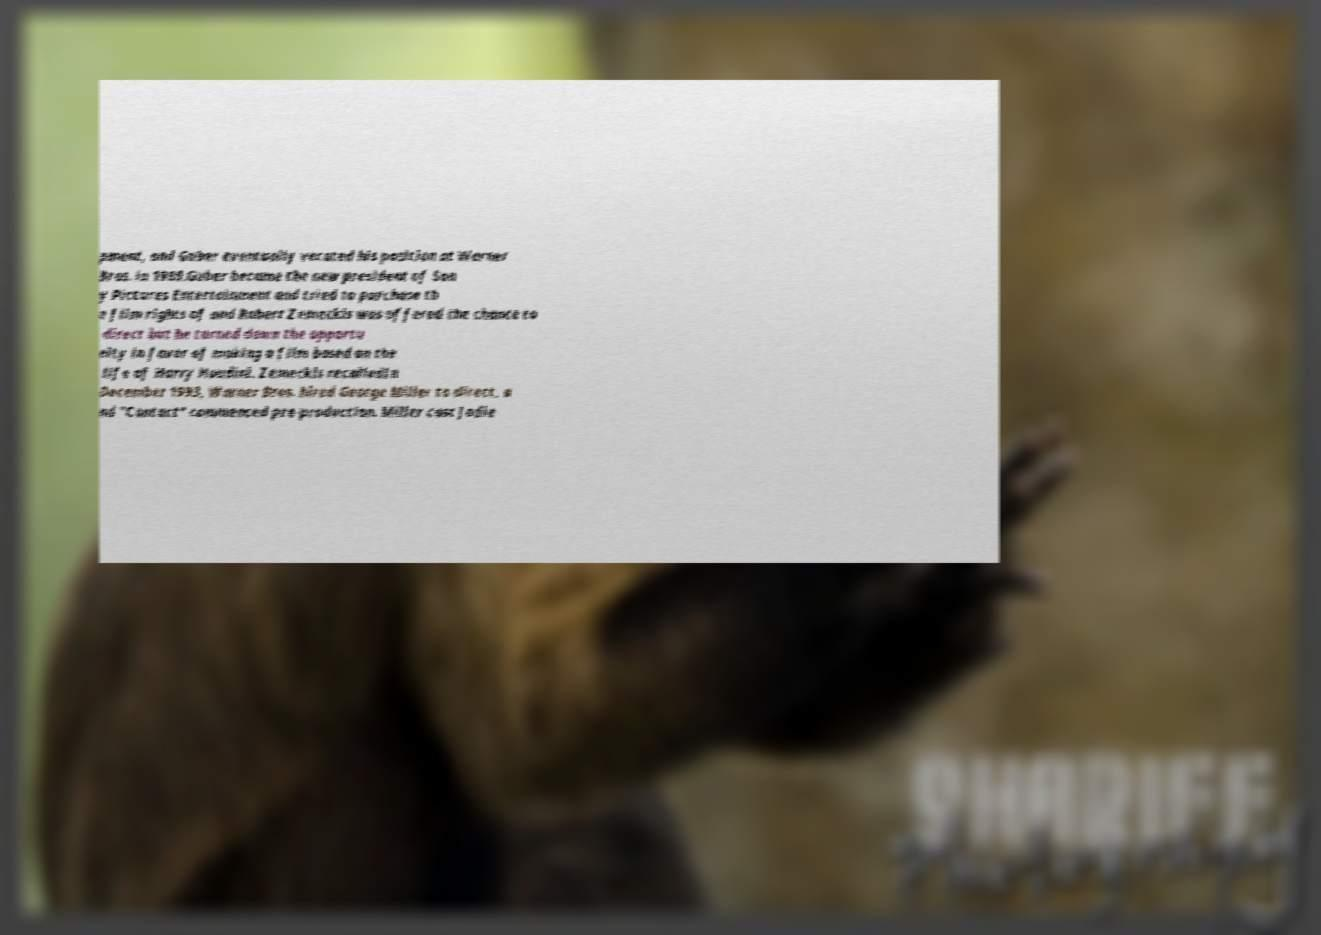There's text embedded in this image that I need extracted. Can you transcribe it verbatim? pment, and Guber eventually vacated his position at Warner Bros. in 1989.Guber became the new president of Son y Pictures Entertainment and tried to purchase th e film rights of and Robert Zemeckis was offered the chance to direct but he turned down the opportu nity in favor of making a film based on the life of Harry Houdini. Zemeckis recalledIn December 1993, Warner Bros. hired George Miller to direct, a nd "Contact" commenced pre-production. Miller cast Jodie 